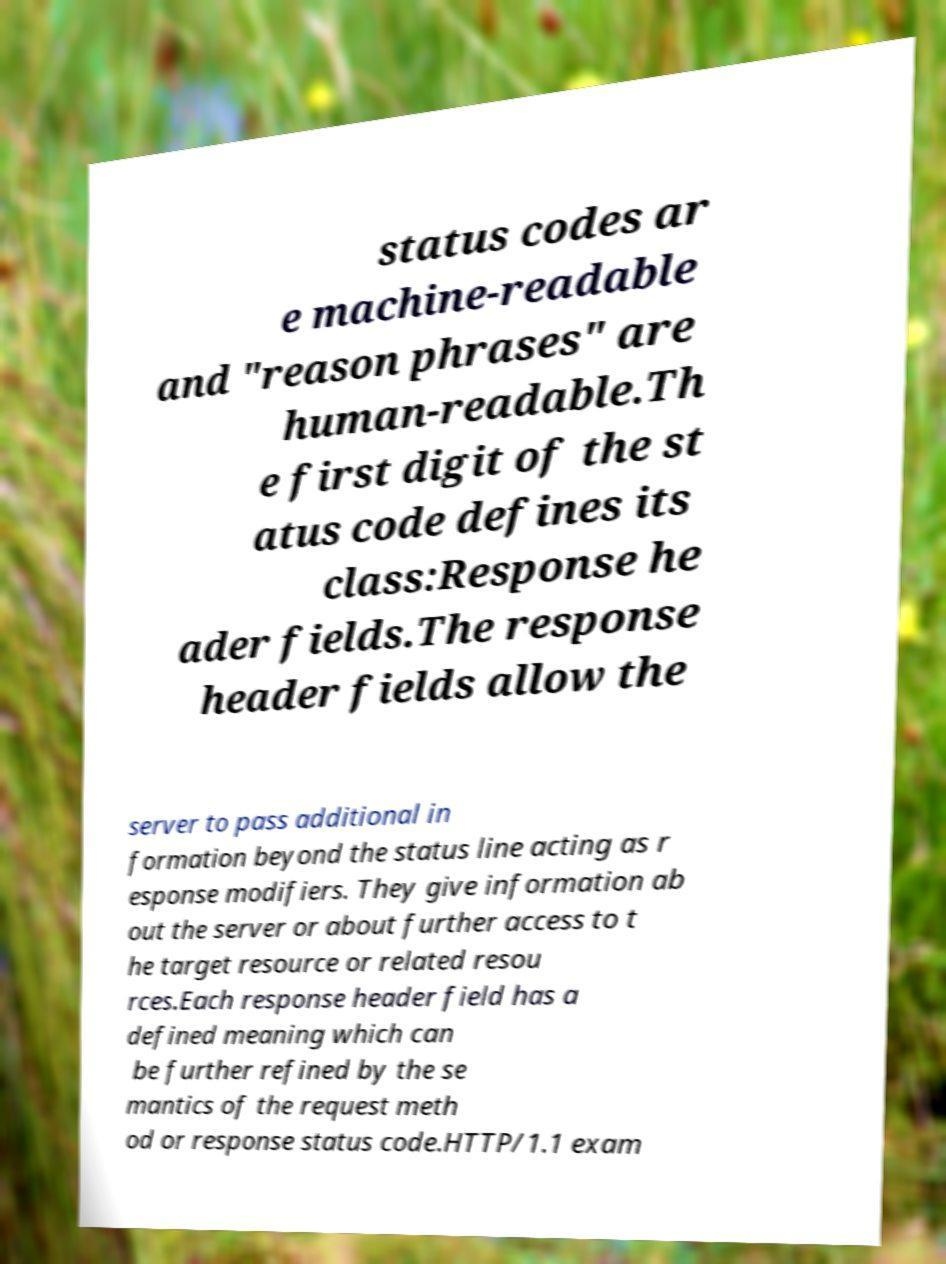What messages or text are displayed in this image? I need them in a readable, typed format. status codes ar e machine-readable and "reason phrases" are human-readable.Th e first digit of the st atus code defines its class:Response he ader fields.The response header fields allow the server to pass additional in formation beyond the status line acting as r esponse modifiers. They give information ab out the server or about further access to t he target resource or related resou rces.Each response header field has a defined meaning which can be further refined by the se mantics of the request meth od or response status code.HTTP/1.1 exam 